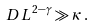<formula> <loc_0><loc_0><loc_500><loc_500>D L ^ { 2 - \gamma } \gg \kappa \, .</formula> 